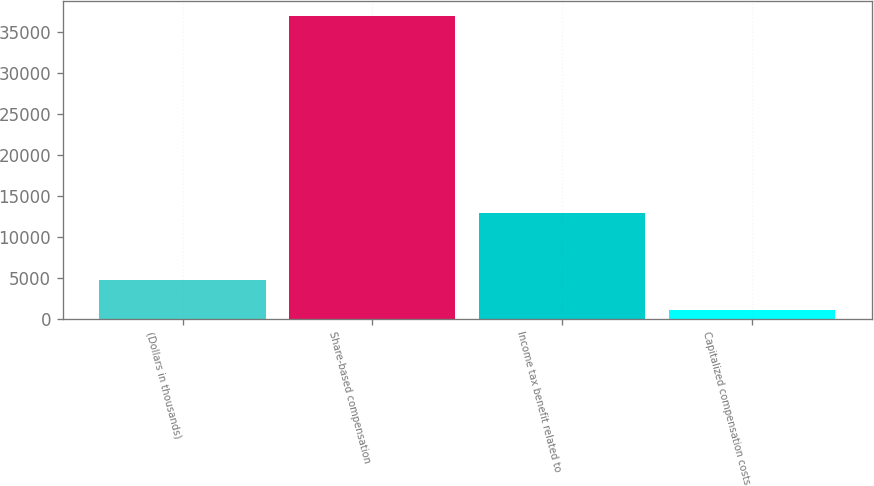<chart> <loc_0><loc_0><loc_500><loc_500><bar_chart><fcel>(Dollars in thousands)<fcel>Share-based compensation<fcel>Income tax benefit related to<fcel>Capitalized compensation costs<nl><fcel>4653.9<fcel>36900<fcel>12845<fcel>1071<nl></chart> 